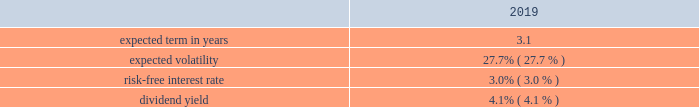Westrock company notes to consolidated financial statements 2014 ( continued ) our results of operations for the fiscal years ended september 30 , 2019 , 2018 and 2017 include share-based compensation expense of $ 64.2 million , $ 66.8 million and $ 60.9 million , respectively , including $ 2.9 million included in the gain on sale of hh&b in fiscal 2017 .
Share-based compensation expense in fiscal 2017 was reduced by $ 5.4 million for the rescission of shares granted to our ceo that were inadvertently granted in excess of plan limits in fiscal 2014 and 2015 .
The total income tax benefit in the results of operations in connection with share-based compensation was $ 16.3 million , $ 19.4 million and $ 22.5 million , for the fiscal years ended september 30 , 2019 , 2018 and 2017 , respectively .
Cash received from share-based payment arrangements for the fiscal years ended september 30 , 2019 , 2018 and 2017 was $ 61.5 million , $ 44.4 million and $ 59.2 million , respectively .
Equity awards issued in connection with acquisitions in connection with the kapstone acquisition , we replaced certain outstanding awards of restricted stock units granted under the kapstone long-term incentive plan with westrock stock options and restricted stock units .
No additional shares will be granted under the kapstone plan .
The kapstone equity awards were replaced with awards with identical terms utilizing an approximately 0.83 conversion factor as described in the merger agreement .
The acquisition consideration included approximately $ 70.8 million related to outstanding kapstone equity awards related to service prior to the effective date of the kapstone acquisition 2013 the balance related to service after the effective date will be expensed over the remaining service period of the awards .
As part of the kapstone acquisition , we issued 2665462 options that were valued at a weighted average fair value of $ 20.99 per share using the black-scholes option pricing model .
The weighted average significant assumptions used were: .
In connection with the mps acquisition , we replaced certain outstanding awards of restricted stock units granted under the mps long-term incentive plan with westrock restricted stock units .
No additional shares will be granted under the mps plan .
The mps equity awards were replaced with identical terms utilizing an approximately 0.33 conversion factor as described in the merger agreement .
As part of the mps acquisition , we granted 119373 awards of restricted stock units , which contain service conditions and were valued at $ 54.24 per share .
The acquisition consideration included approximately $ 1.9 million related to outstanding mps equity awards related to service prior to the effective date of the mps acquisition 2013 the balance related to service after the effective date will be expensed over the remaining service period of the awards .
Stock options and stock appreciation rights stock options granted under our plans generally have an exercise price equal to the closing market price on the date of the grant , generally vest in three years , in either one tranche or in approximately one-third increments , and have 10-year contractual terms .
However , a portion of our grants are subject to earlier expense recognition due to retirement eligibility rules .
Presently , other than circumstances such as death , disability and retirement , grants will include a provision requiring both a change of control and termination of employment to accelerate vesting .
At the date of grant , we estimate the fair value of stock options granted using a black-scholes option pricing model .
We use historical data to estimate option exercises and employee terminations in determining the expected term in years for stock options .
Expected volatility is calculated based on the historical volatility of our stock .
The risk-free interest rate is based on u.s .
Treasury securities in effect at the date of the grant of the stock options .
The dividend yield is estimated based on our historic annual dividend payments and current expectations for the future .
Other than in connection with replacement awards in connection with acquisitions , we did not grant any stock options in fiscal 2019 , 2018 and 2017. .
What was the total value of the options issued in the kapstone acquisition ? ( $ )? 
Computations: (2665462 * 20.99)
Answer: 55948047.38. 